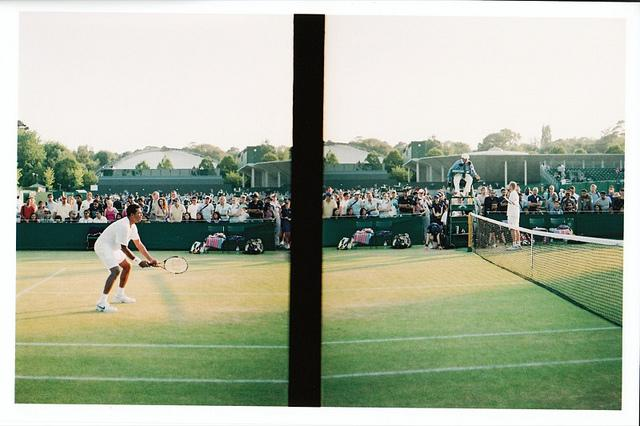Who is the person sitting high above the tennis net? referee 